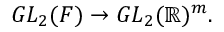Convert formula to latex. <formula><loc_0><loc_0><loc_500><loc_500>G L _ { 2 } ( F ) \to G L _ { 2 } ( \mathbb { R } ) ^ { m } .</formula> 